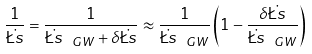<formula> <loc_0><loc_0><loc_500><loc_500>\frac { 1 } { \dot { \L s } } = \frac { 1 } { \dot { \L s } _ { \ G W } + \delta \dot { \L s } } \approx \frac { 1 } { \dot { \L s } _ { \ G W } } \left ( 1 - \frac { \delta \dot { \L s } } { \dot { \L s } _ { \ G W } } \right )</formula> 